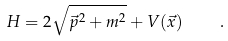<formula> <loc_0><loc_0><loc_500><loc_500>H = 2 \sqrt { \vec { p } ^ { 2 } + m ^ { 2 } } + V ( \vec { x } ) \quad .</formula> 